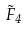<formula> <loc_0><loc_0><loc_500><loc_500>\tilde { F } _ { 4 }</formula> 